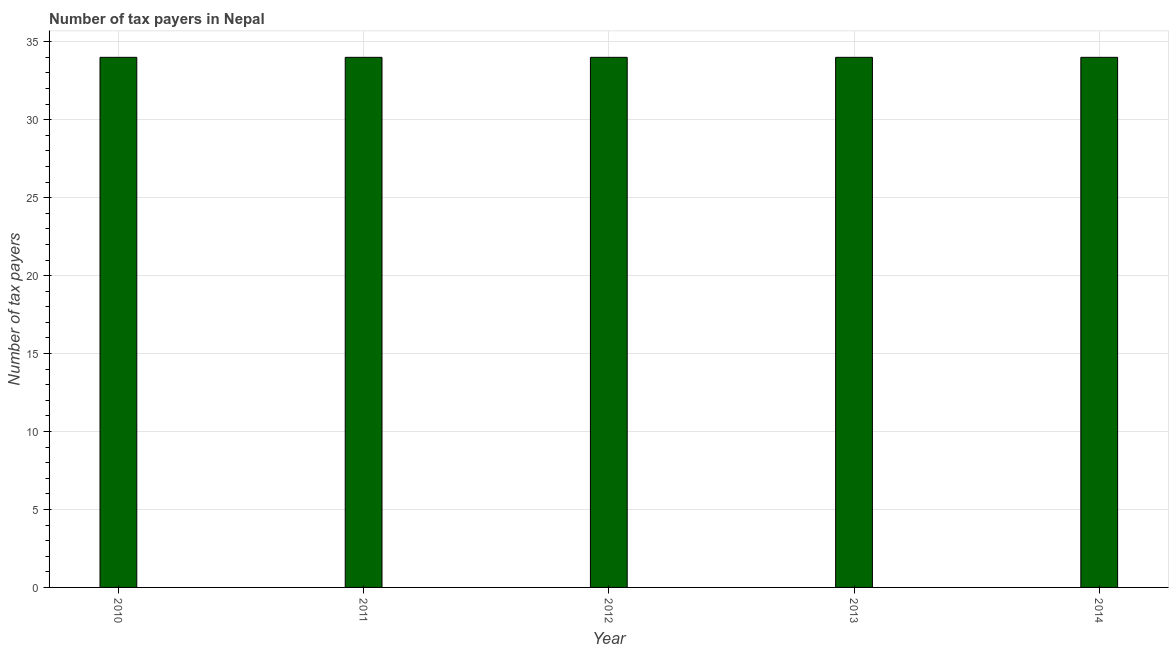What is the title of the graph?
Make the answer very short. Number of tax payers in Nepal. What is the label or title of the X-axis?
Provide a succinct answer. Year. What is the label or title of the Y-axis?
Your answer should be very brief. Number of tax payers. Across all years, what is the maximum number of tax payers?
Keep it short and to the point. 34. What is the sum of the number of tax payers?
Ensure brevity in your answer.  170. Is the difference between the number of tax payers in 2010 and 2011 greater than the difference between any two years?
Give a very brief answer. Yes. In how many years, is the number of tax payers greater than the average number of tax payers taken over all years?
Your response must be concise. 0. How many bars are there?
Offer a terse response. 5. Are all the bars in the graph horizontal?
Give a very brief answer. No. What is the difference between two consecutive major ticks on the Y-axis?
Your response must be concise. 5. What is the Number of tax payers of 2010?
Your answer should be compact. 34. What is the Number of tax payers in 2011?
Offer a terse response. 34. What is the Number of tax payers of 2012?
Offer a terse response. 34. What is the difference between the Number of tax payers in 2010 and 2013?
Ensure brevity in your answer.  0. What is the difference between the Number of tax payers in 2010 and 2014?
Provide a short and direct response. 0. What is the difference between the Number of tax payers in 2011 and 2013?
Provide a short and direct response. 0. What is the difference between the Number of tax payers in 2012 and 2013?
Give a very brief answer. 0. What is the difference between the Number of tax payers in 2012 and 2014?
Give a very brief answer. 0. What is the difference between the Number of tax payers in 2013 and 2014?
Offer a very short reply. 0. What is the ratio of the Number of tax payers in 2010 to that in 2011?
Your answer should be compact. 1. What is the ratio of the Number of tax payers in 2010 to that in 2013?
Your answer should be compact. 1. What is the ratio of the Number of tax payers in 2012 to that in 2013?
Give a very brief answer. 1. What is the ratio of the Number of tax payers in 2013 to that in 2014?
Your response must be concise. 1. 